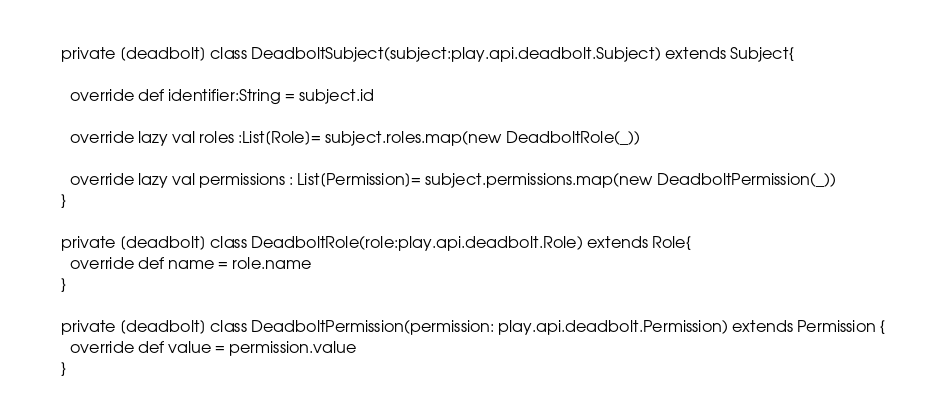Convert code to text. <code><loc_0><loc_0><loc_500><loc_500><_Scala_>
private [deadbolt] class DeadboltSubject(subject:play.api.deadbolt.Subject) extends Subject{

  override def identifier:String = subject.id

  override lazy val roles :List[Role]= subject.roles.map(new DeadboltRole(_))

  override lazy val permissions : List[Permission]= subject.permissions.map(new DeadboltPermission(_))
}

private [deadbolt] class DeadboltRole(role:play.api.deadbolt.Role) extends Role{
  override def name = role.name
}

private [deadbolt] class DeadboltPermission(permission: play.api.deadbolt.Permission) extends Permission {
  override def value = permission.value
}
</code> 